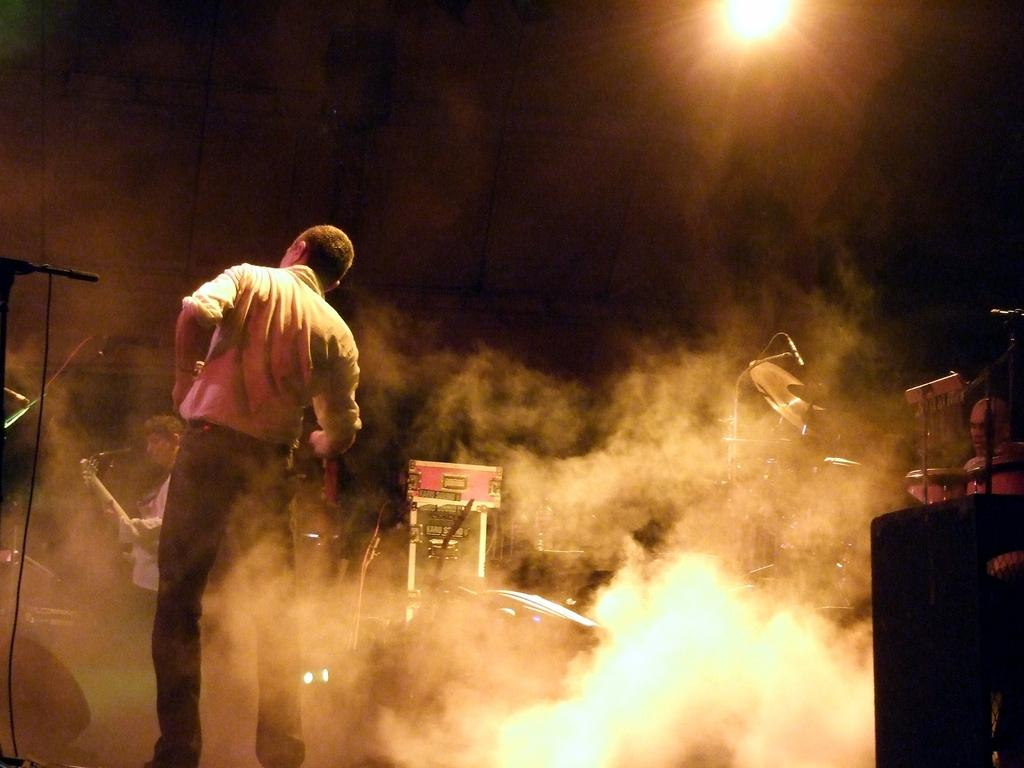How many people are in the image? There are two persons standing on the floor on the left side of the image. What can be seen at the top of the image? There is a light visible at the top of the image. What is the weather condition in the image? There is fog in the middle of the image, which suggests a foggy condition. What objects are present in the image related to music? Musical instruments are present in the image. What date is circled on the calendar in the image? There is no calendar present in the image. What sound can be heard during the thunderstorm in the image? There is no thunderstorm or thunder sound present in the image. 